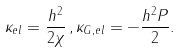Convert formula to latex. <formula><loc_0><loc_0><loc_500><loc_500>\kappa _ { e l } = \frac { h ^ { 2 } } { 2 \chi } \, , \kappa _ { G , e l } = - \frac { h ^ { 2 } P } { 2 } .</formula> 